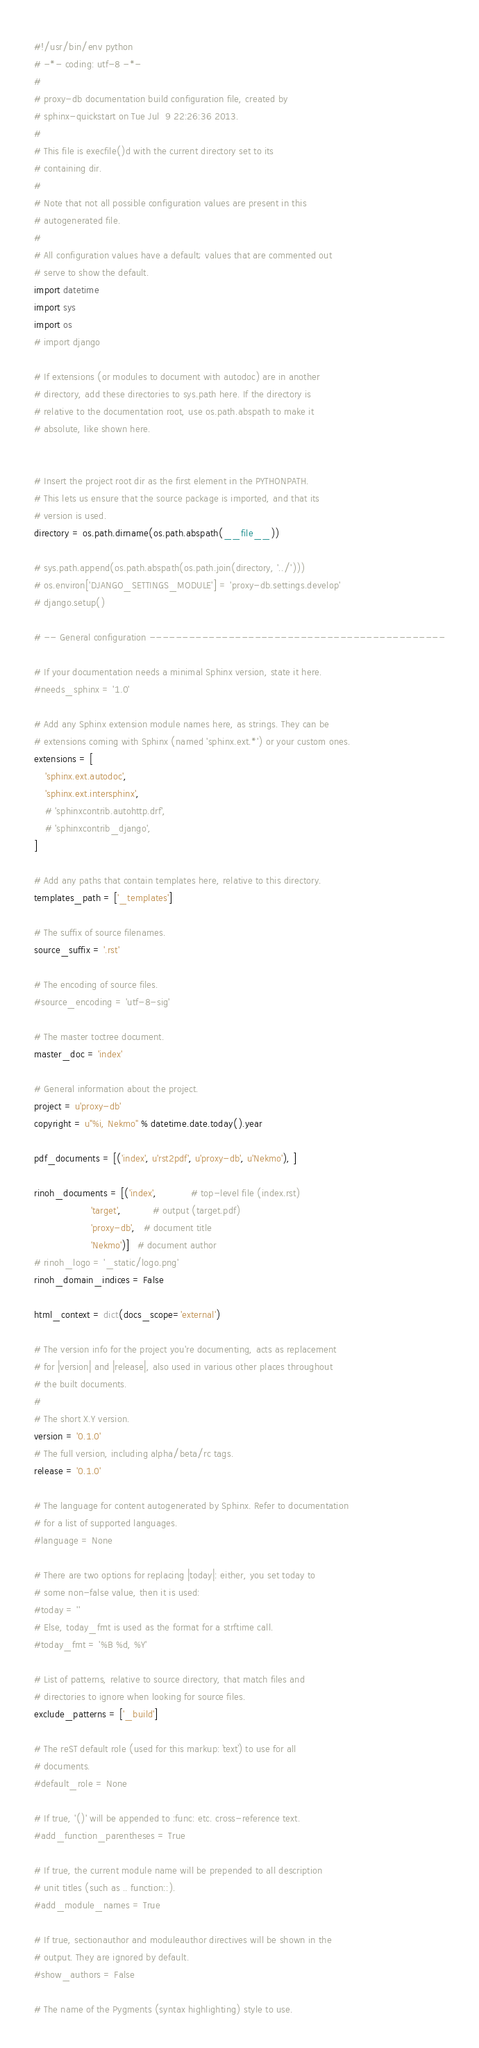Convert code to text. <code><loc_0><loc_0><loc_500><loc_500><_Python_>#!/usr/bin/env python
# -*- coding: utf-8 -*-
#
# proxy-db documentation build configuration file, created by
# sphinx-quickstart on Tue Jul  9 22:26:36 2013.
#
# This file is execfile()d with the current directory set to its
# containing dir.
#
# Note that not all possible configuration values are present in this
# autogenerated file.
#
# All configuration values have a default; values that are commented out
# serve to show the default.
import datetime
import sys
import os
# import django

# If extensions (or modules to document with autodoc) are in another
# directory, add these directories to sys.path here. If the directory is
# relative to the documentation root, use os.path.abspath to make it
# absolute, like shown here.


# Insert the project root dir as the first element in the PYTHONPATH.
# This lets us ensure that the source package is imported, and that its
# version is used.
directory = os.path.dirname(os.path.abspath(__file__))

# sys.path.append(os.path.abspath(os.path.join(directory, '../')))
# os.environ['DJANGO_SETTINGS_MODULE'] = 'proxy-db.settings.develop'
# django.setup()

# -- General configuration ---------------------------------------------

# If your documentation needs a minimal Sphinx version, state it here.
#needs_sphinx = '1.0'

# Add any Sphinx extension module names here, as strings. They can be
# extensions coming with Sphinx (named 'sphinx.ext.*') or your custom ones.
extensions = [
    'sphinx.ext.autodoc',
    'sphinx.ext.intersphinx',
    # 'sphinxcontrib.autohttp.drf',
    # 'sphinxcontrib_django',
]

# Add any paths that contain templates here, relative to this directory.
templates_path = ['_templates']

# The suffix of source filenames.
source_suffix = '.rst'

# The encoding of source files.
#source_encoding = 'utf-8-sig'

# The master toctree document.
master_doc = 'index'

# General information about the project.
project = u'proxy-db'
copyright = u"%i, Nekmo" % datetime.date.today().year

pdf_documents = [('index', u'rst2pdf', u'proxy-db', u'Nekmo'), ]

rinoh_documents = [('index',            # top-level file (index.rst)
                    'target',           # output (target.pdf)
                    'proxy-db',   # document title
                    'Nekmo')]   # document author
# rinoh_logo = '_static/logo.png'
rinoh_domain_indices = False

html_context = dict(docs_scope='external')

# The version info for the project you're documenting, acts as replacement
# for |version| and |release|, also used in various other places throughout
# the built documents.
#
# The short X.Y version.
version = '0.1.0'
# The full version, including alpha/beta/rc tags.
release = '0.1.0'

# The language for content autogenerated by Sphinx. Refer to documentation
# for a list of supported languages.
#language = None

# There are two options for replacing |today|: either, you set today to
# some non-false value, then it is used:
#today = ''
# Else, today_fmt is used as the format for a strftime call.
#today_fmt = '%B %d, %Y'

# List of patterns, relative to source directory, that match files and
# directories to ignore when looking for source files.
exclude_patterns = ['_build']

# The reST default role (used for this markup: `text`) to use for all
# documents.
#default_role = None

# If true, '()' will be appended to :func: etc. cross-reference text.
#add_function_parentheses = True

# If true, the current module name will be prepended to all description
# unit titles (such as .. function::).
#add_module_names = True

# If true, sectionauthor and moduleauthor directives will be shown in the
# output. They are ignored by default.
#show_authors = False

# The name of the Pygments (syntax highlighting) style to use.</code> 